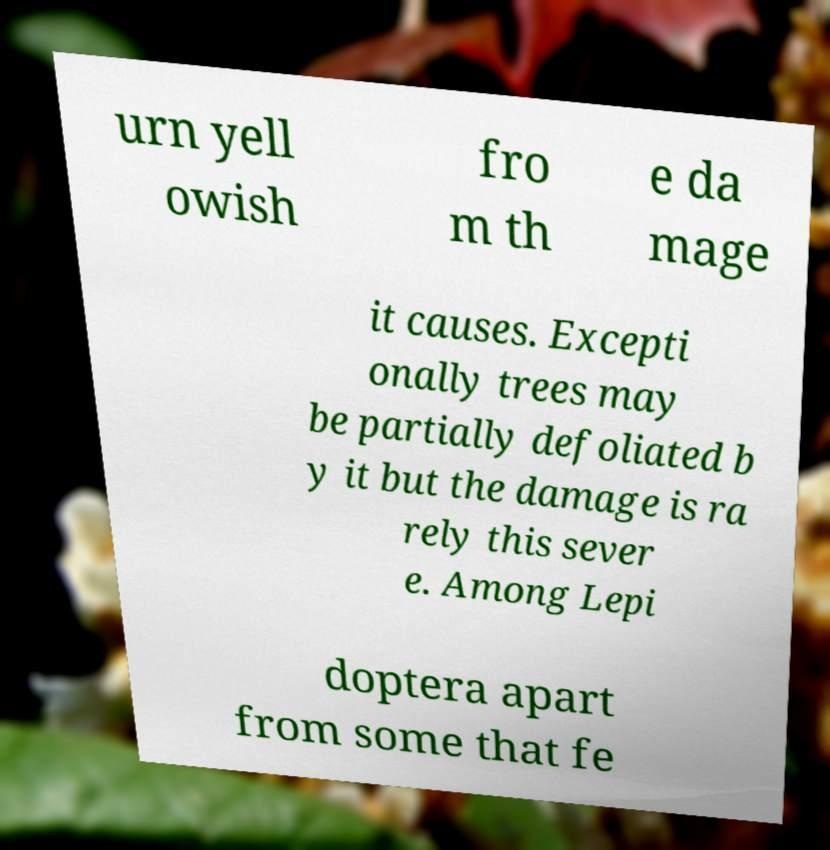There's text embedded in this image that I need extracted. Can you transcribe it verbatim? urn yell owish fro m th e da mage it causes. Excepti onally trees may be partially defoliated b y it but the damage is ra rely this sever e. Among Lepi doptera apart from some that fe 